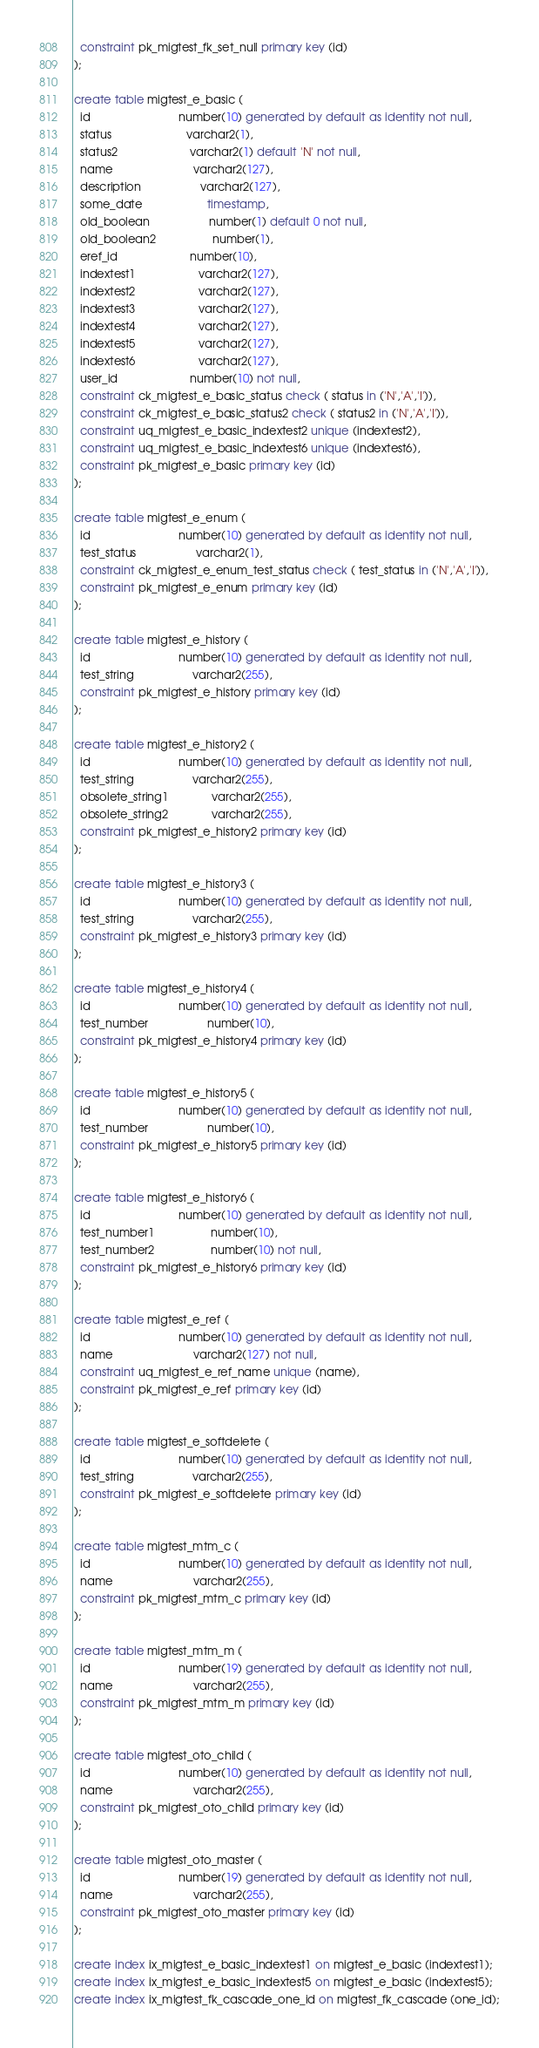<code> <loc_0><loc_0><loc_500><loc_500><_SQL_>  constraint pk_migtest_fk_set_null primary key (id)
);

create table migtest_e_basic (
  id                            number(10) generated by default as identity not null,
  status                        varchar2(1),
  status2                       varchar2(1) default 'N' not null,
  name                          varchar2(127),
  description                   varchar2(127),
  some_date                     timestamp,
  old_boolean                   number(1) default 0 not null,
  old_boolean2                  number(1),
  eref_id                       number(10),
  indextest1                    varchar2(127),
  indextest2                    varchar2(127),
  indextest3                    varchar2(127),
  indextest4                    varchar2(127),
  indextest5                    varchar2(127),
  indextest6                    varchar2(127),
  user_id                       number(10) not null,
  constraint ck_migtest_e_basic_status check ( status in ('N','A','I')),
  constraint ck_migtest_e_basic_status2 check ( status2 in ('N','A','I')),
  constraint uq_migtest_e_basic_indextest2 unique (indextest2),
  constraint uq_migtest_e_basic_indextest6 unique (indextest6),
  constraint pk_migtest_e_basic primary key (id)
);

create table migtest_e_enum (
  id                            number(10) generated by default as identity not null,
  test_status                   varchar2(1),
  constraint ck_migtest_e_enum_test_status check ( test_status in ('N','A','I')),
  constraint pk_migtest_e_enum primary key (id)
);

create table migtest_e_history (
  id                            number(10) generated by default as identity not null,
  test_string                   varchar2(255),
  constraint pk_migtest_e_history primary key (id)
);

create table migtest_e_history2 (
  id                            number(10) generated by default as identity not null,
  test_string                   varchar2(255),
  obsolete_string1              varchar2(255),
  obsolete_string2              varchar2(255),
  constraint pk_migtest_e_history2 primary key (id)
);

create table migtest_e_history3 (
  id                            number(10) generated by default as identity not null,
  test_string                   varchar2(255),
  constraint pk_migtest_e_history3 primary key (id)
);

create table migtest_e_history4 (
  id                            number(10) generated by default as identity not null,
  test_number                   number(10),
  constraint pk_migtest_e_history4 primary key (id)
);

create table migtest_e_history5 (
  id                            number(10) generated by default as identity not null,
  test_number                   number(10),
  constraint pk_migtest_e_history5 primary key (id)
);

create table migtest_e_history6 (
  id                            number(10) generated by default as identity not null,
  test_number1                  number(10),
  test_number2                  number(10) not null,
  constraint pk_migtest_e_history6 primary key (id)
);

create table migtest_e_ref (
  id                            number(10) generated by default as identity not null,
  name                          varchar2(127) not null,
  constraint uq_migtest_e_ref_name unique (name),
  constraint pk_migtest_e_ref primary key (id)
);

create table migtest_e_softdelete (
  id                            number(10) generated by default as identity not null,
  test_string                   varchar2(255),
  constraint pk_migtest_e_softdelete primary key (id)
);

create table migtest_mtm_c (
  id                            number(10) generated by default as identity not null,
  name                          varchar2(255),
  constraint pk_migtest_mtm_c primary key (id)
);

create table migtest_mtm_m (
  id                            number(19) generated by default as identity not null,
  name                          varchar2(255),
  constraint pk_migtest_mtm_m primary key (id)
);

create table migtest_oto_child (
  id                            number(10) generated by default as identity not null,
  name                          varchar2(255),
  constraint pk_migtest_oto_child primary key (id)
);

create table migtest_oto_master (
  id                            number(19) generated by default as identity not null,
  name                          varchar2(255),
  constraint pk_migtest_oto_master primary key (id)
);

create index ix_migtest_e_basic_indextest1 on migtest_e_basic (indextest1);
create index ix_migtest_e_basic_indextest5 on migtest_e_basic (indextest5);
create index ix_migtest_fk_cascade_one_id on migtest_fk_cascade (one_id);</code> 